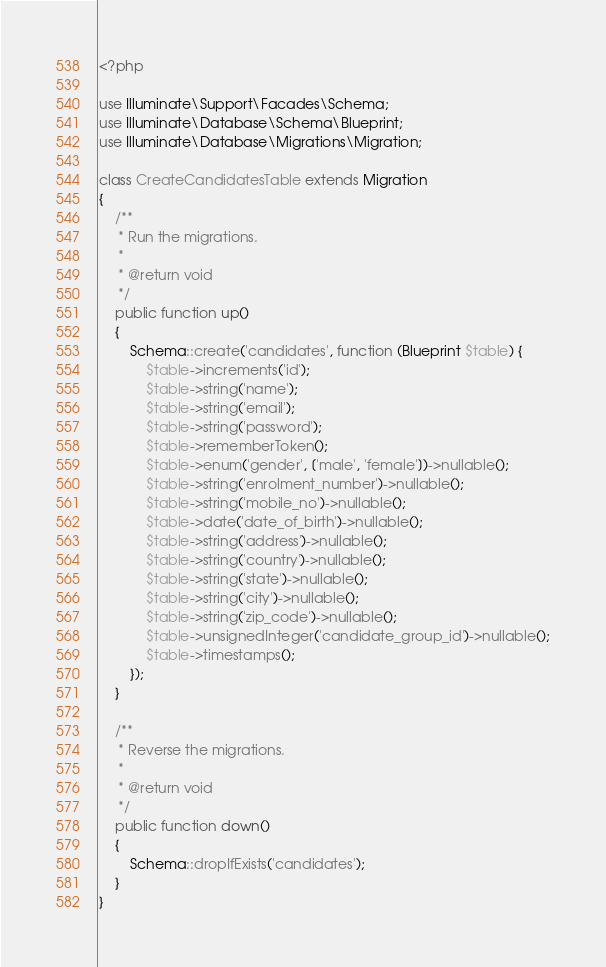Convert code to text. <code><loc_0><loc_0><loc_500><loc_500><_PHP_><?php

use Illuminate\Support\Facades\Schema;
use Illuminate\Database\Schema\Blueprint;
use Illuminate\Database\Migrations\Migration;

class CreateCandidatesTable extends Migration
{
    /**
     * Run the migrations.
     *
     * @return void
     */
    public function up()
    {
        Schema::create('candidates', function (Blueprint $table) {
            $table->increments('id');
            $table->string('name');
            $table->string('email');
            $table->string('password');
            $table->rememberToken();
            $table->enum('gender', ['male', 'female'])->nullable();
            $table->string('enrolment_number')->nullable();
            $table->string('mobile_no')->nullable();
            $table->date('date_of_birth')->nullable();
            $table->string('address')->nullable();
            $table->string('country')->nullable();
            $table->string('state')->nullable();
            $table->string('city')->nullable();
            $table->string('zip_code')->nullable();
            $table->unsignedInteger('candidate_group_id')->nullable();
            $table->timestamps();
        });
    }

    /**
     * Reverse the migrations.
     *
     * @return void
     */
    public function down()
    {
        Schema::dropIfExists('candidates');
    }
}
</code> 